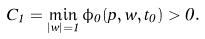Convert formula to latex. <formula><loc_0><loc_0><loc_500><loc_500>C _ { 1 } = \min _ { | w | = 1 } \phi _ { 0 } ( p , w , t _ { 0 } ) > 0 .</formula> 